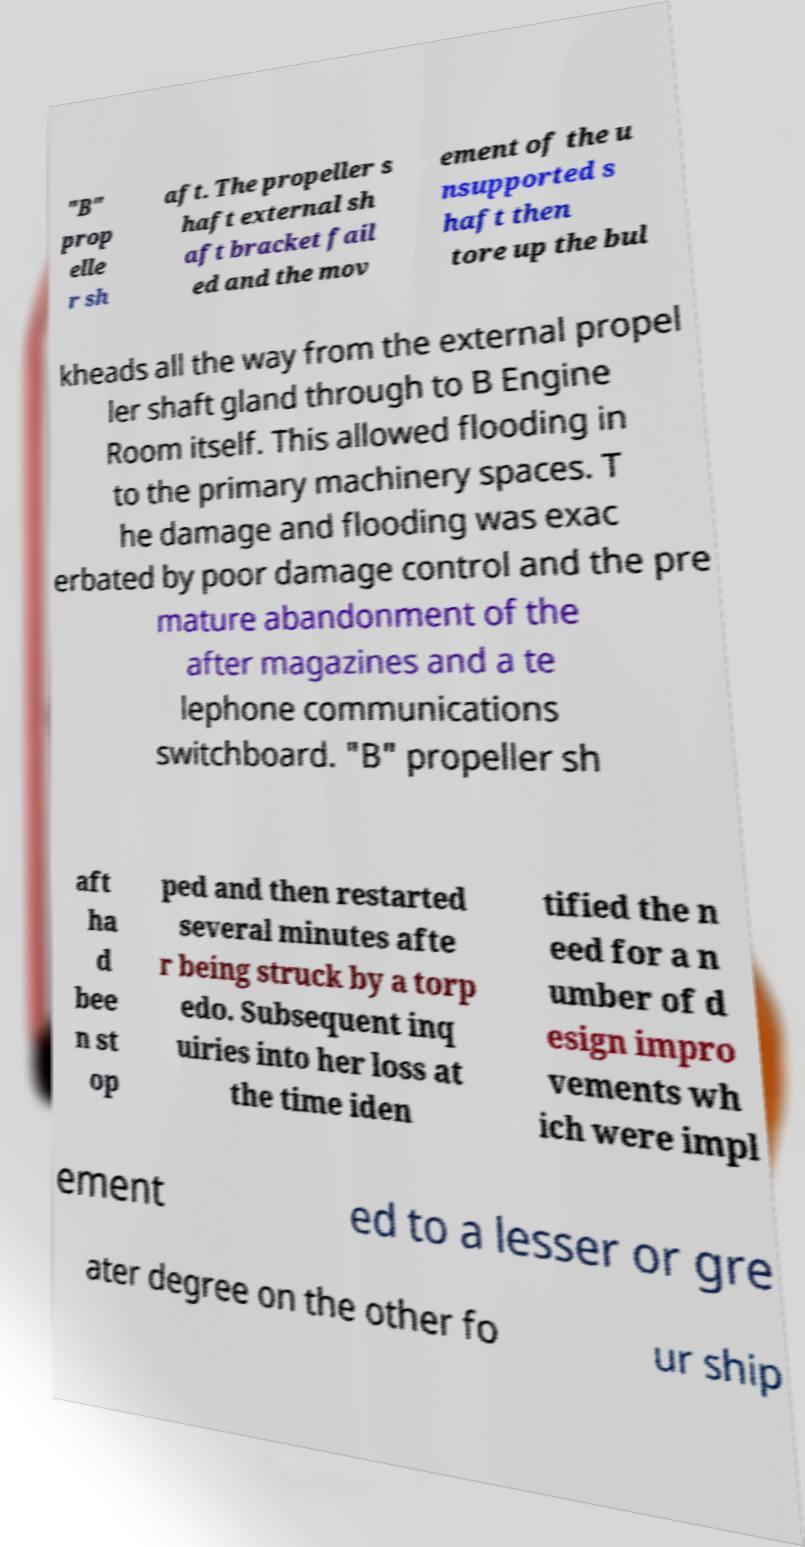There's text embedded in this image that I need extracted. Can you transcribe it verbatim? "B" prop elle r sh aft. The propeller s haft external sh aft bracket fail ed and the mov ement of the u nsupported s haft then tore up the bul kheads all the way from the external propel ler shaft gland through to B Engine Room itself. This allowed flooding in to the primary machinery spaces. T he damage and flooding was exac erbated by poor damage control and the pre mature abandonment of the after magazines and a te lephone communications switchboard. "B" propeller sh aft ha d bee n st op ped and then restarted several minutes afte r being struck by a torp edo. Subsequent inq uiries into her loss at the time iden tified the n eed for a n umber of d esign impro vements wh ich were impl ement ed to a lesser or gre ater degree on the other fo ur ship 